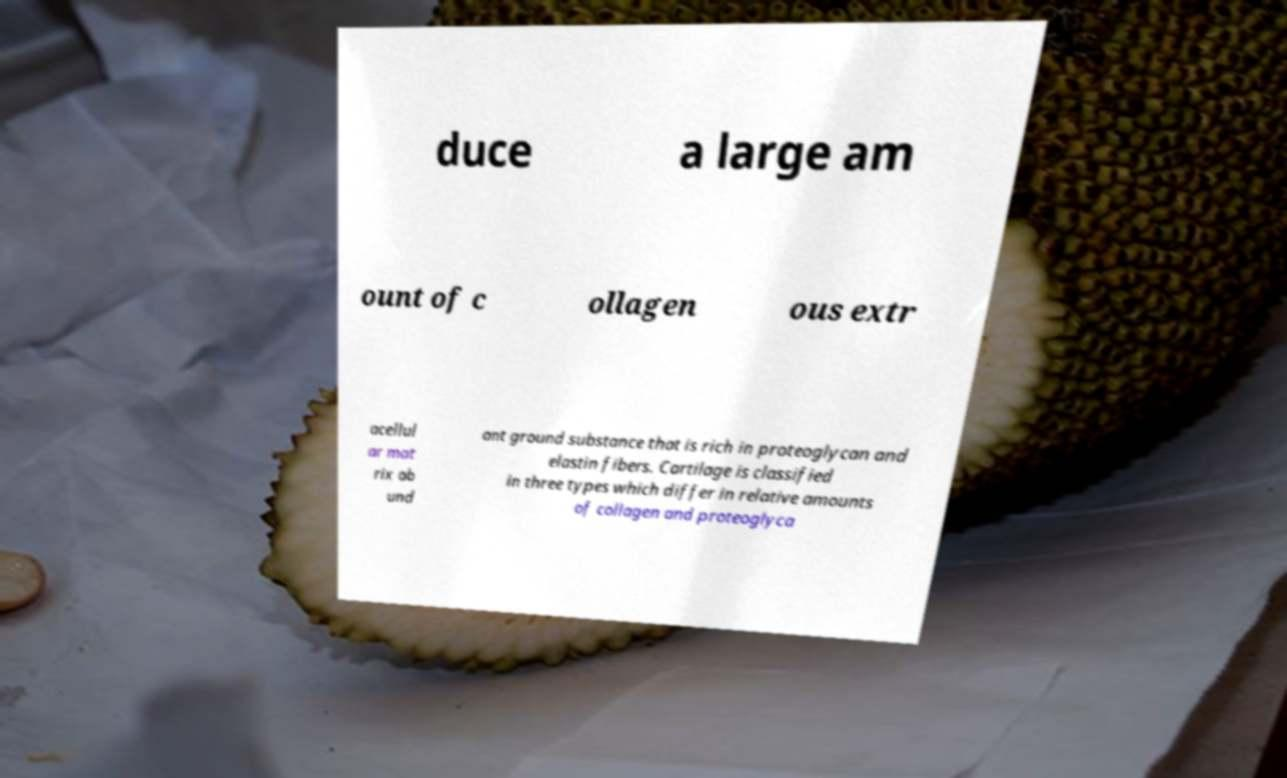For documentation purposes, I need the text within this image transcribed. Could you provide that? duce a large am ount of c ollagen ous extr acellul ar mat rix ab und ant ground substance that is rich in proteoglycan and elastin fibers. Cartilage is classified in three types which differ in relative amounts of collagen and proteoglyca 